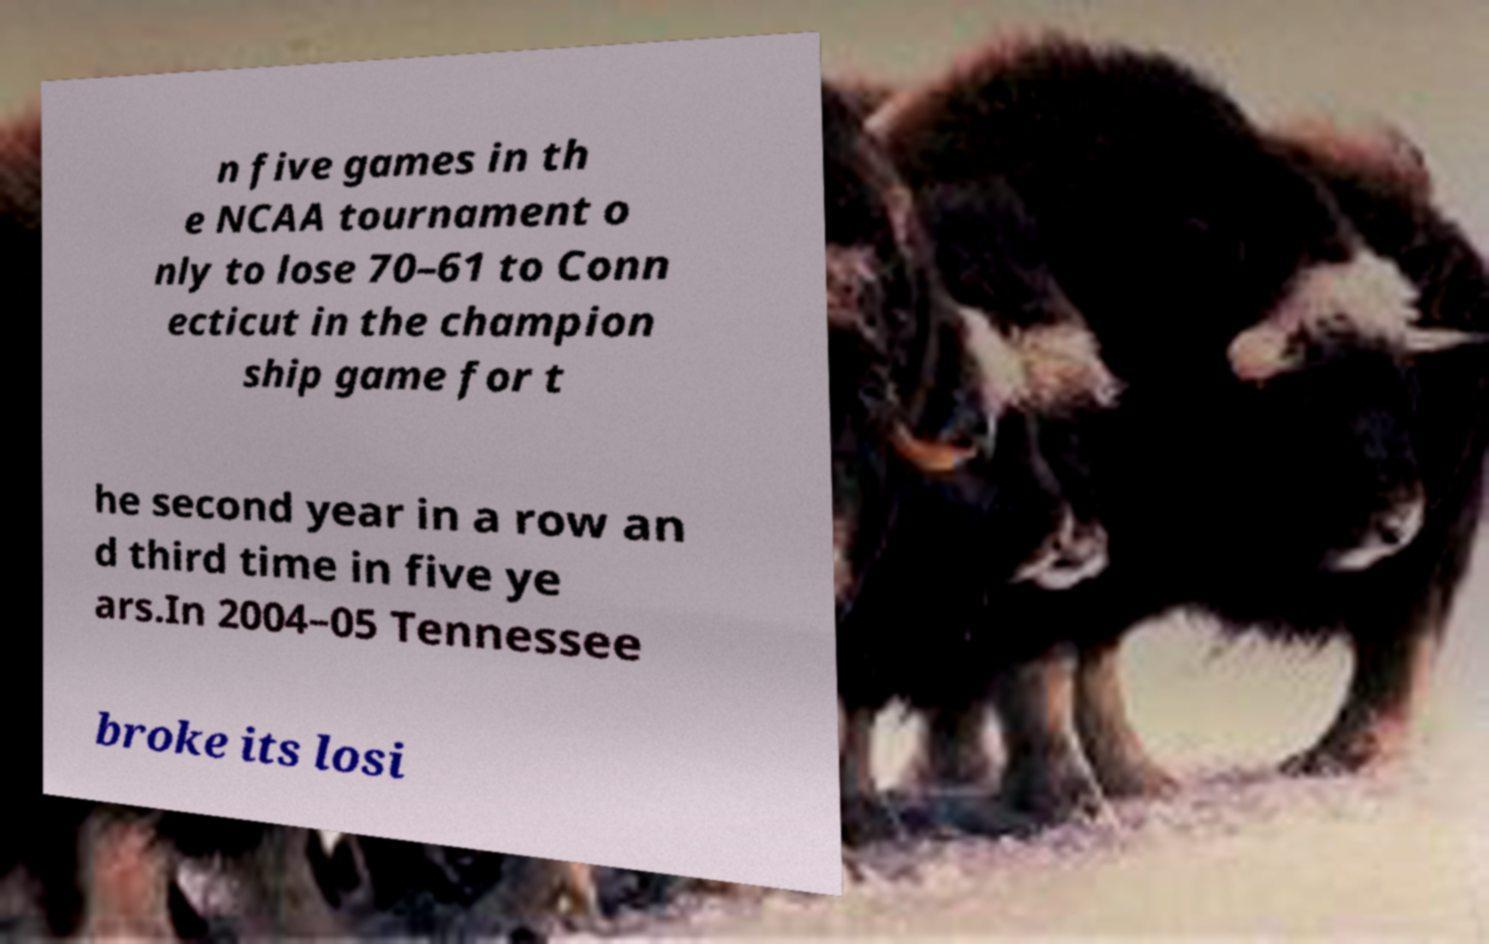For documentation purposes, I need the text within this image transcribed. Could you provide that? n five games in th e NCAA tournament o nly to lose 70–61 to Conn ecticut in the champion ship game for t he second year in a row an d third time in five ye ars.In 2004–05 Tennessee broke its losi 